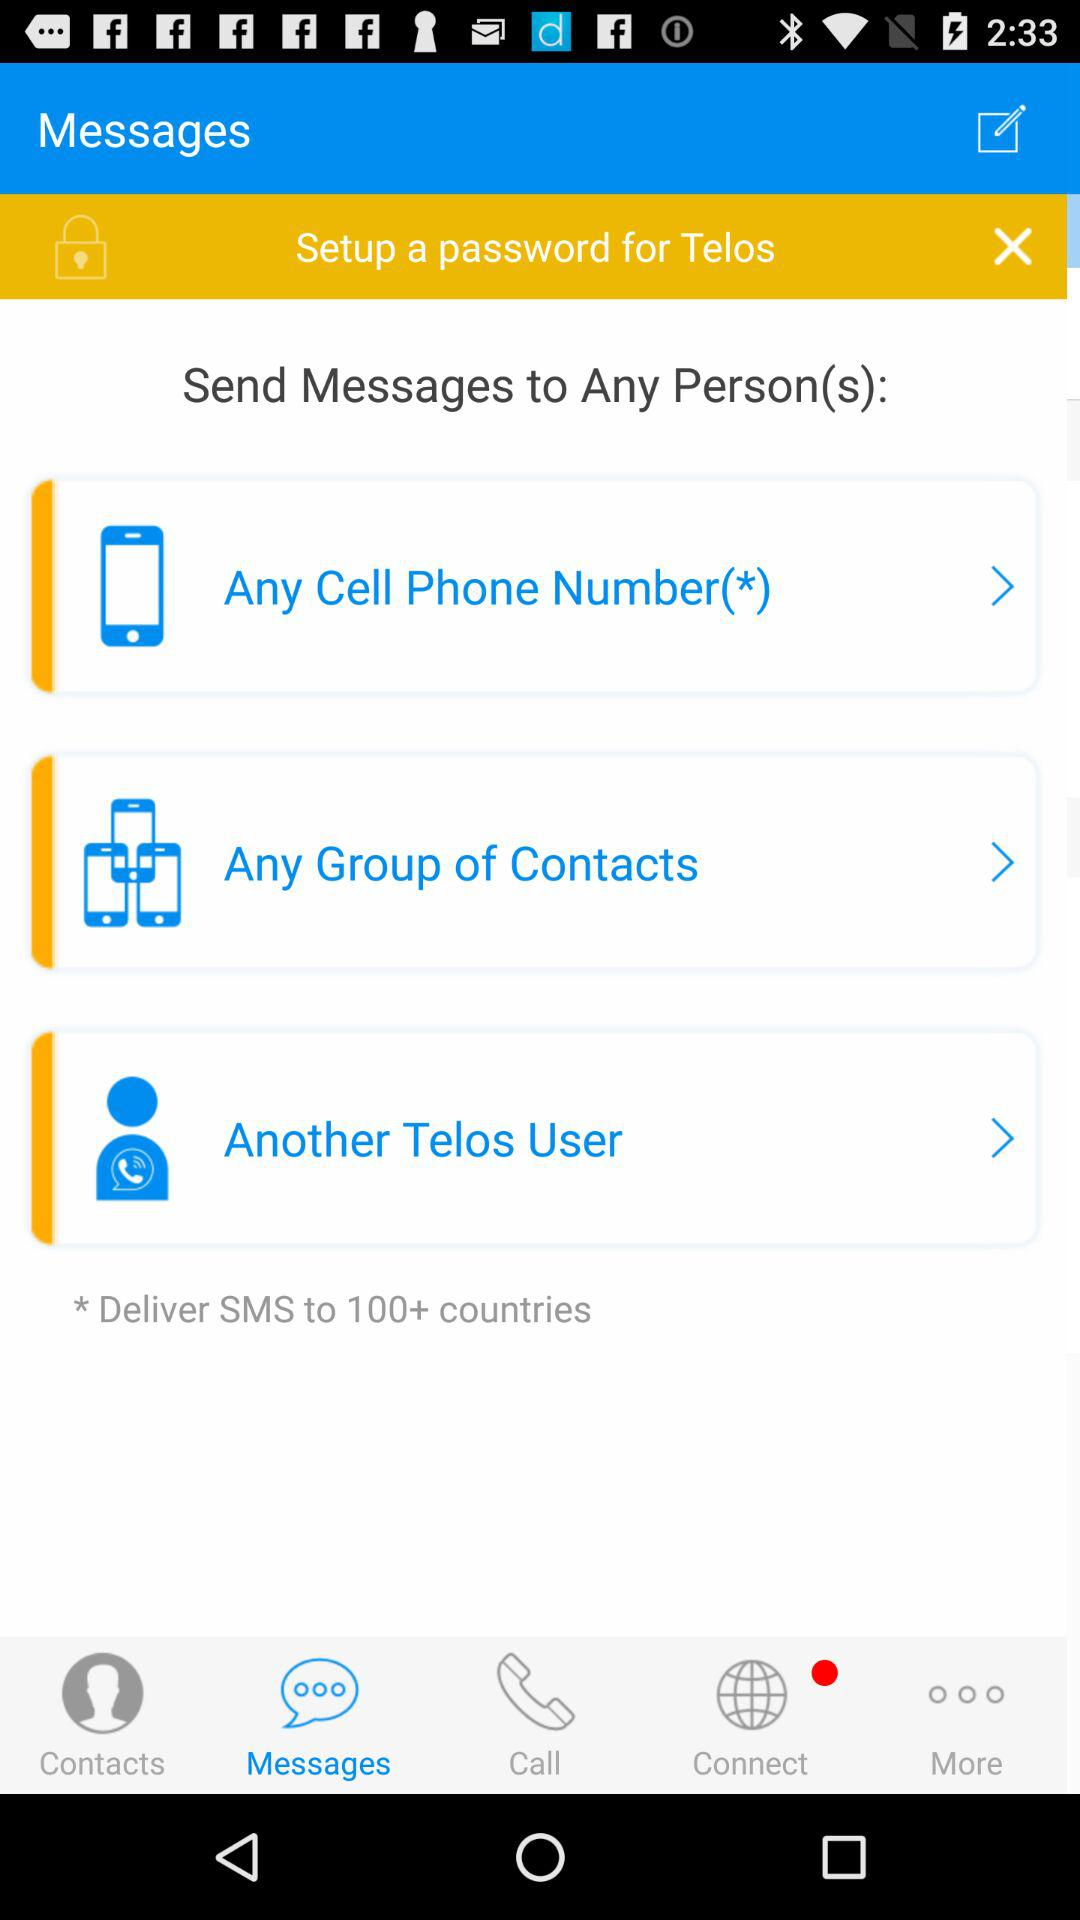How many options does the user have to send a message to?
Answer the question using a single word or phrase. 3 